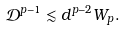Convert formula to latex. <formula><loc_0><loc_0><loc_500><loc_500>\mathcal { D } ^ { p - 1 } \lesssim d ^ { p - 2 } W _ { p } .</formula> 